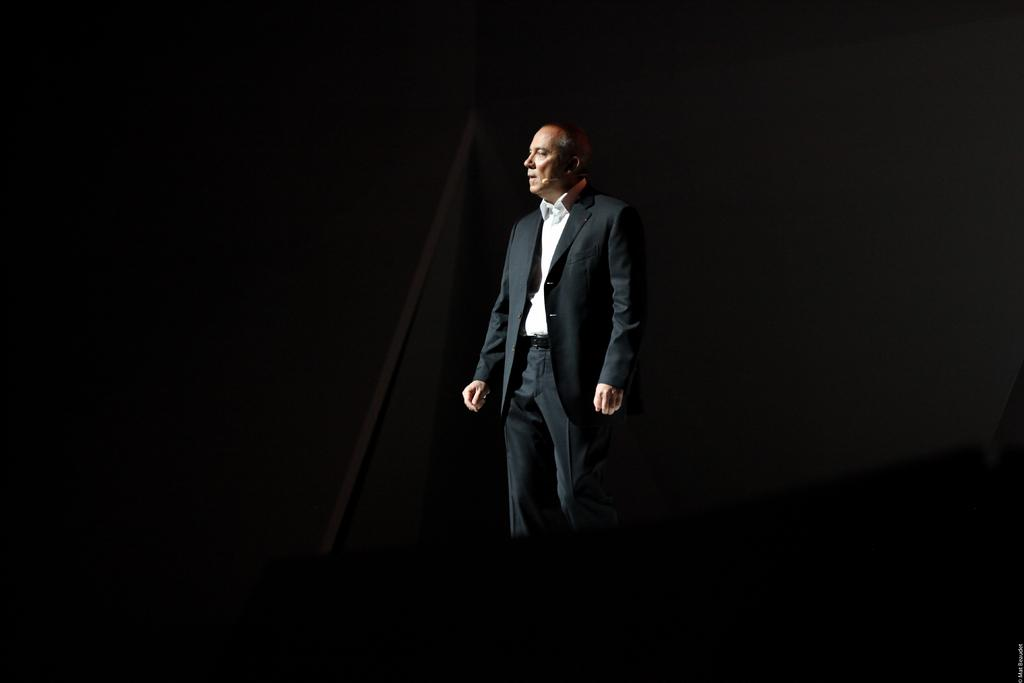Who is present in the image? There is a man in the image. What is the man wearing in the image? The man is wearing a black jacket. Can you describe the lighting in the image? The image is dark. What type of magic is the man performing in the image? There is no indication of magic or any magical activity in the image. 